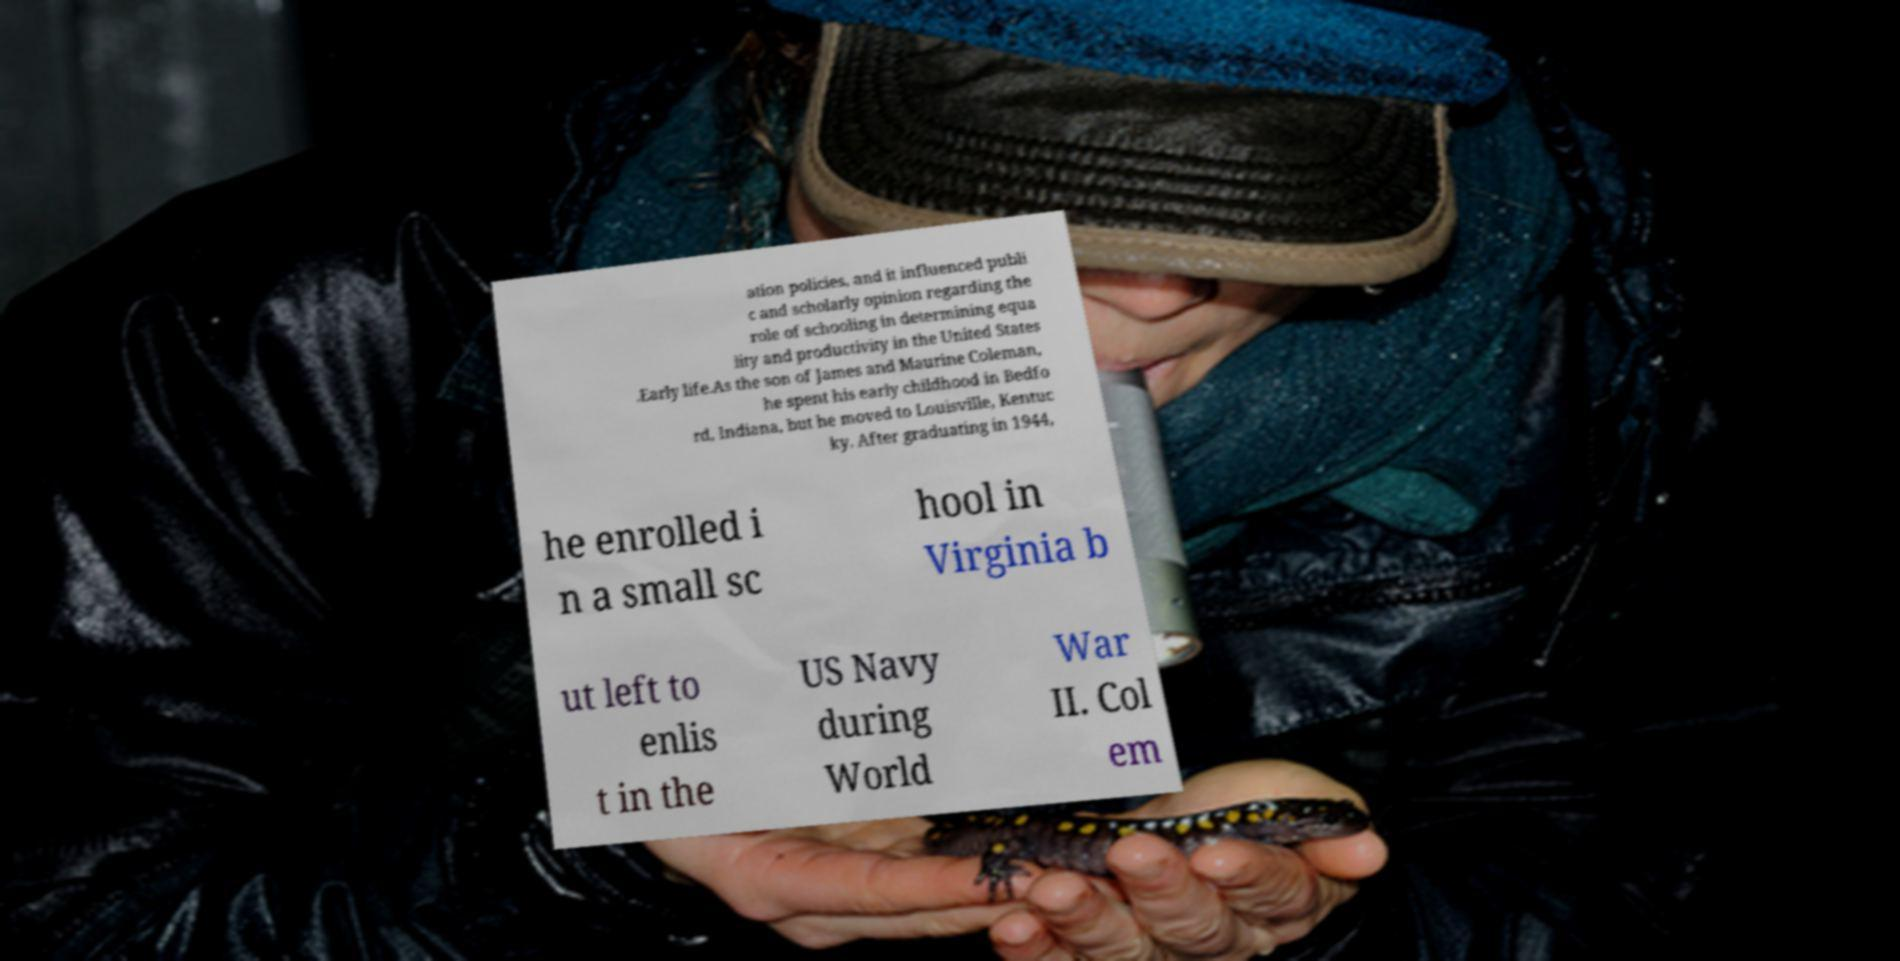For documentation purposes, I need the text within this image transcribed. Could you provide that? ation policies, and it influenced publi c and scholarly opinion regarding the role of schooling in determining equa lity and productivity in the United States .Early life.As the son of James and Maurine Coleman, he spent his early childhood in Bedfo rd, Indiana, but he moved to Louisville, Kentuc ky. After graduating in 1944, he enrolled i n a small sc hool in Virginia b ut left to enlis t in the US Navy during World War II. Col em 